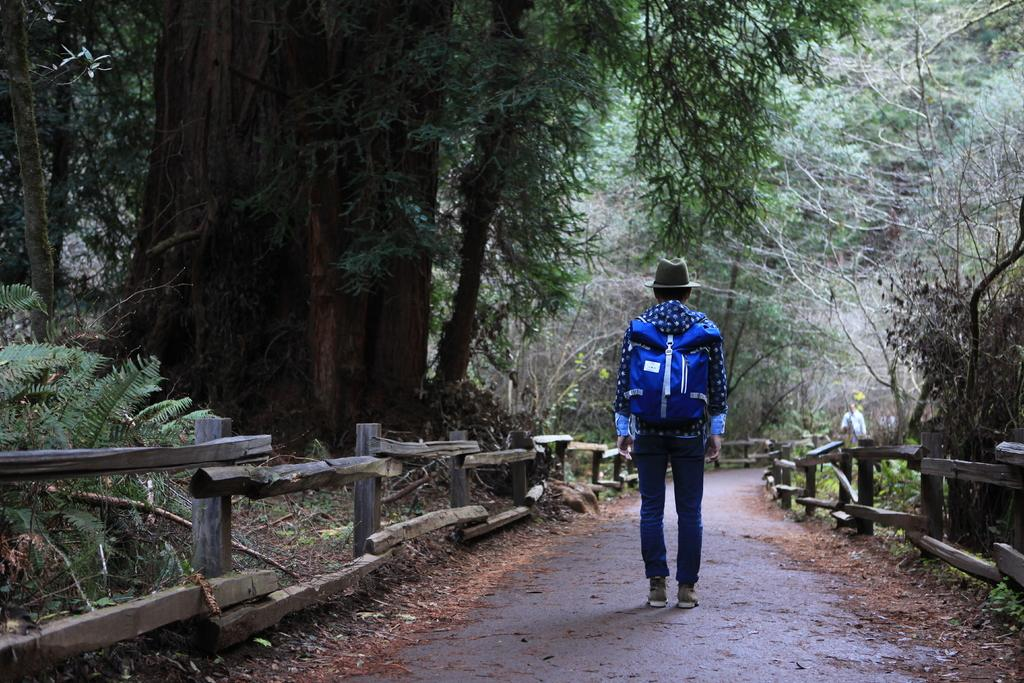What is the main subject of the image? There is a person standing in the image. What is the person wearing on their body? The person is wearing a blue color bag. What type of headwear is the person wearing? The person is wearing a hat. What type of vegetation can be seen in the image? There are trees visible in the image. What type of fencing can be seen in the image? There is wooden fencing in the image. Can you see any deer or toads interacting with the person in the image? There is no deer or toad present in the image; it only features a person standing, wearing a blue color bag and a hat, with trees and wooden fencing in the background. 